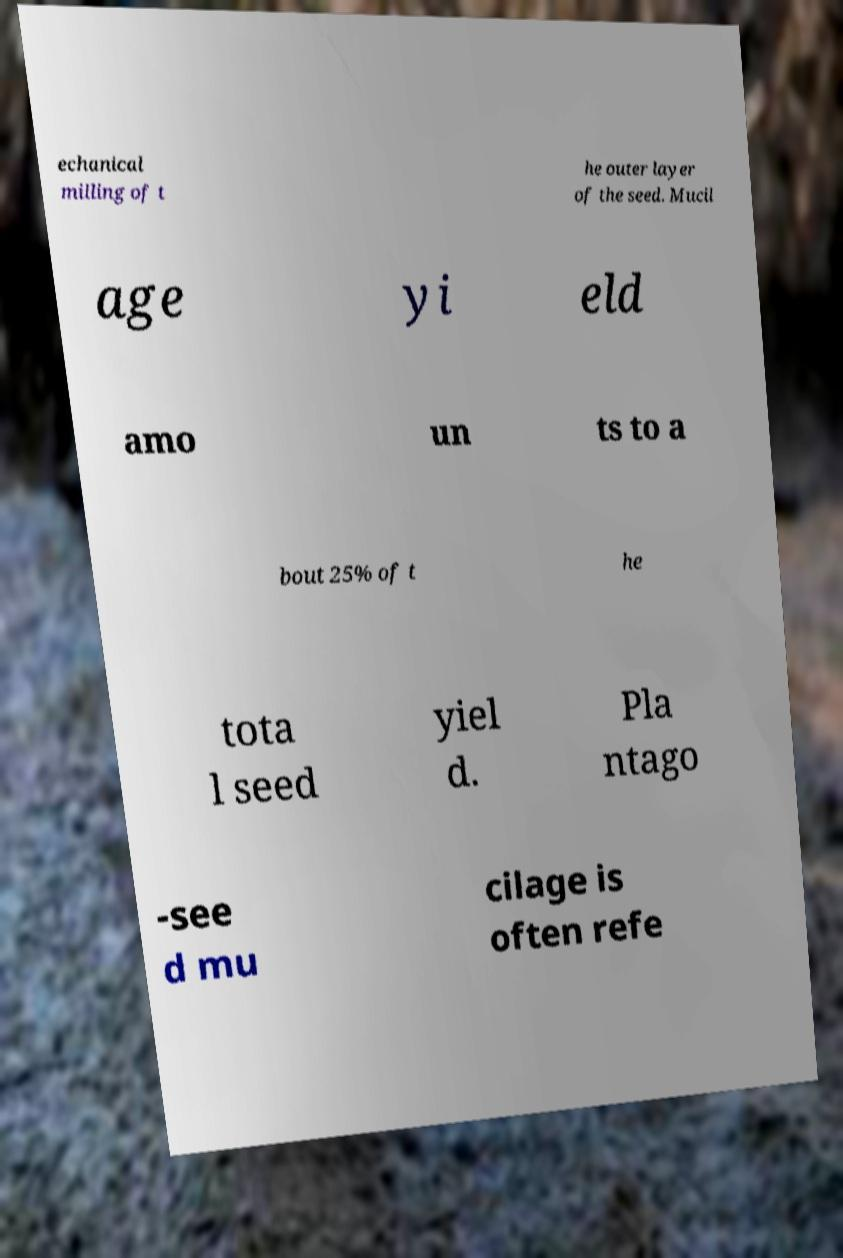Please read and relay the text visible in this image. What does it say? echanical milling of t he outer layer of the seed. Mucil age yi eld amo un ts to a bout 25% of t he tota l seed yiel d. Pla ntago -see d mu cilage is often refe 